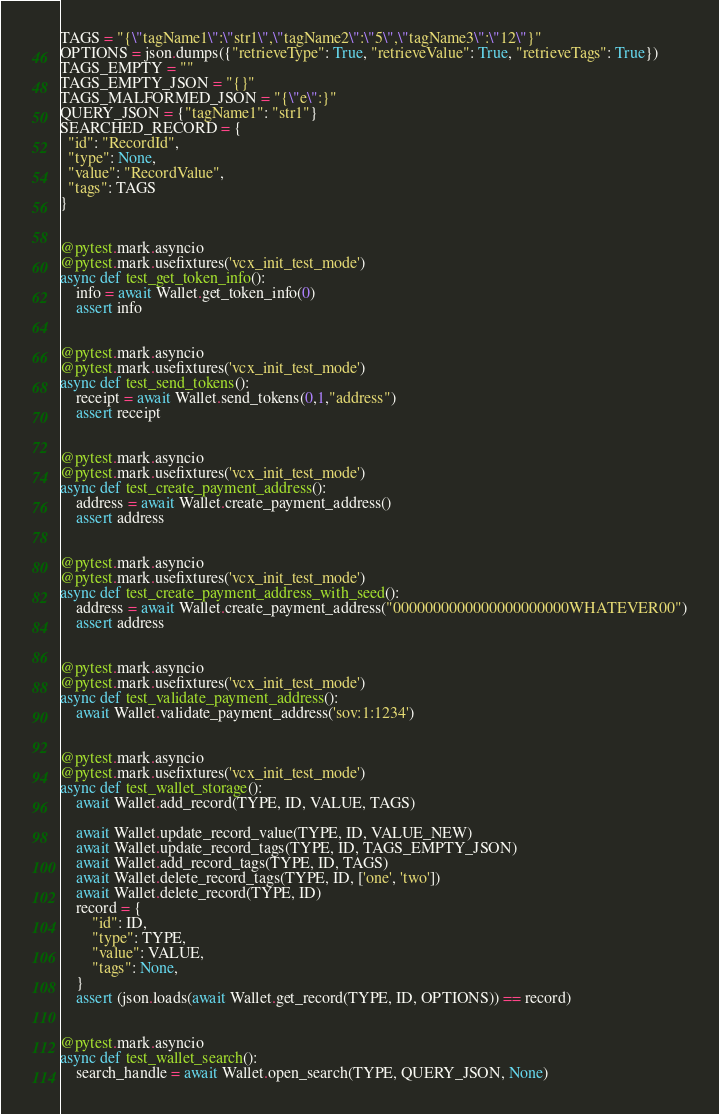Convert code to text. <code><loc_0><loc_0><loc_500><loc_500><_Python_>TAGS = "{\"tagName1\":\"str1\",\"tagName2\":\"5\",\"tagName3\":\"12\"}"
OPTIONS = json.dumps({"retrieveType": True, "retrieveValue": True, "retrieveTags": True})
TAGS_EMPTY = ""
TAGS_EMPTY_JSON = "{}"
TAGS_MALFORMED_JSON = "{\"e\":}"
QUERY_JSON = {"tagName1": "str1"}
SEARCHED_RECORD = {
  "id": "RecordId",
  "type": None,
  "value": "RecordValue",
  "tags": TAGS
}


@pytest.mark.asyncio
@pytest.mark.usefixtures('vcx_init_test_mode')
async def test_get_token_info():
    info = await Wallet.get_token_info(0)
    assert info


@pytest.mark.asyncio
@pytest.mark.usefixtures('vcx_init_test_mode')
async def test_send_tokens():
    receipt = await Wallet.send_tokens(0,1,"address")
    assert receipt


@pytest.mark.asyncio
@pytest.mark.usefixtures('vcx_init_test_mode')
async def test_create_payment_address():
    address = await Wallet.create_payment_address()
    assert address


@pytest.mark.asyncio
@pytest.mark.usefixtures('vcx_init_test_mode')
async def test_create_payment_address_with_seed():
    address = await Wallet.create_payment_address("0000000000000000000000WHATEVER00")
    assert address


@pytest.mark.asyncio
@pytest.mark.usefixtures('vcx_init_test_mode')
async def test_validate_payment_address():
    await Wallet.validate_payment_address('sov:1:1234')


@pytest.mark.asyncio
@pytest.mark.usefixtures('vcx_init_test_mode')
async def test_wallet_storage():
    await Wallet.add_record(TYPE, ID, VALUE, TAGS)

    await Wallet.update_record_value(TYPE, ID, VALUE_NEW)
    await Wallet.update_record_tags(TYPE, ID, TAGS_EMPTY_JSON)
    await Wallet.add_record_tags(TYPE, ID, TAGS)
    await Wallet.delete_record_tags(TYPE, ID, ['one', 'two'])
    await Wallet.delete_record(TYPE, ID)
    record = {
        "id": ID,
        "type": TYPE,
        "value": VALUE,
        "tags": None,
    }
    assert (json.loads(await Wallet.get_record(TYPE, ID, OPTIONS)) == record)


@pytest.mark.asyncio
async def test_wallet_search():
    search_handle = await Wallet.open_search(TYPE, QUERY_JSON, None)</code> 